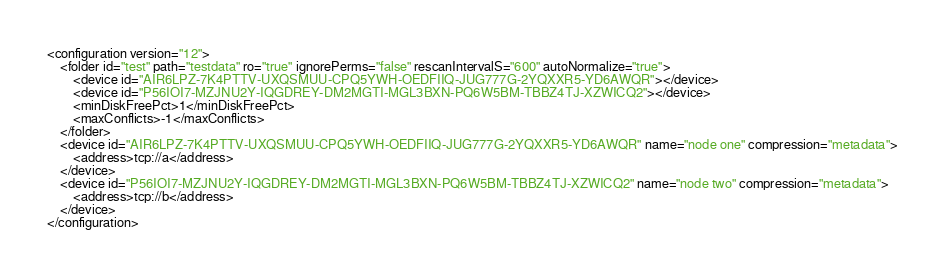Convert code to text. <code><loc_0><loc_0><loc_500><loc_500><_XML_><configuration version="12">
    <folder id="test" path="testdata" ro="true" ignorePerms="false" rescanIntervalS="600" autoNormalize="true">
        <device id="AIR6LPZ-7K4PTTV-UXQSMUU-CPQ5YWH-OEDFIIQ-JUG777G-2YQXXR5-YD6AWQR"></device>
        <device id="P56IOI7-MZJNU2Y-IQGDREY-DM2MGTI-MGL3BXN-PQ6W5BM-TBBZ4TJ-XZWICQ2"></device>
        <minDiskFreePct>1</minDiskFreePct>
        <maxConflicts>-1</maxConflicts>
    </folder>
    <device id="AIR6LPZ-7K4PTTV-UXQSMUU-CPQ5YWH-OEDFIIQ-JUG777G-2YQXXR5-YD6AWQR" name="node one" compression="metadata">
        <address>tcp://a</address>
    </device>
    <device id="P56IOI7-MZJNU2Y-IQGDREY-DM2MGTI-MGL3BXN-PQ6W5BM-TBBZ4TJ-XZWICQ2" name="node two" compression="metadata">
        <address>tcp://b</address>
    </device>
</configuration>
</code> 